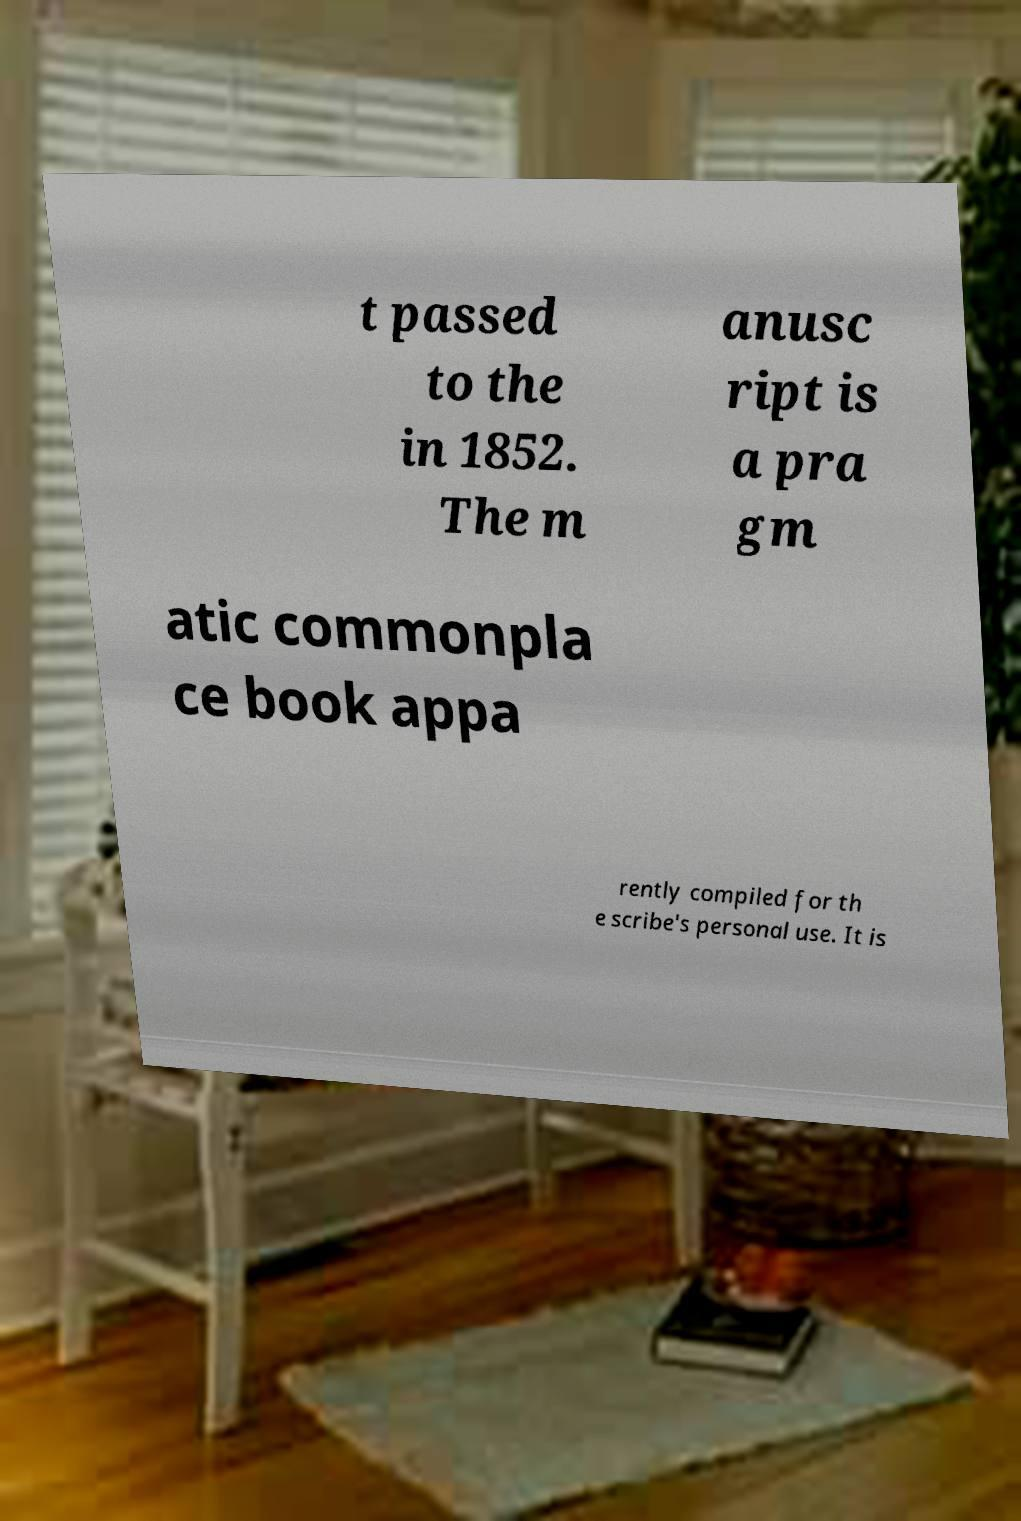Please identify and transcribe the text found in this image. t passed to the in 1852. The m anusc ript is a pra gm atic commonpla ce book appa rently compiled for th e scribe's personal use. It is 